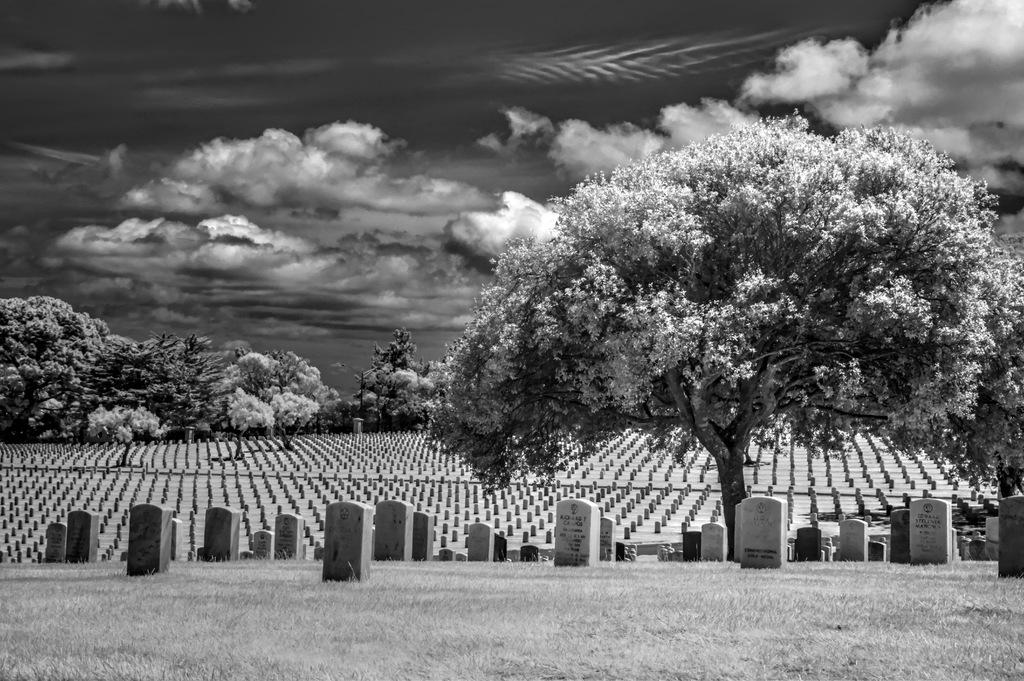What is located in the foreground of the image? There are cemeteries in the foreground of the image. What type of vegetation is at the bottom of the image? There is grass at the bottom of the image. What can be seen in the background of the image? There are trees in the background of the image. What is visible at the top of the image? The sky is visible at the top of the image. What type of quartz can be seen in the image? There is no quartz present in the image. What is the limit of the cemeteries in the image? The provided facts do not mention any limits or boundaries for the cemeteries in the image. 